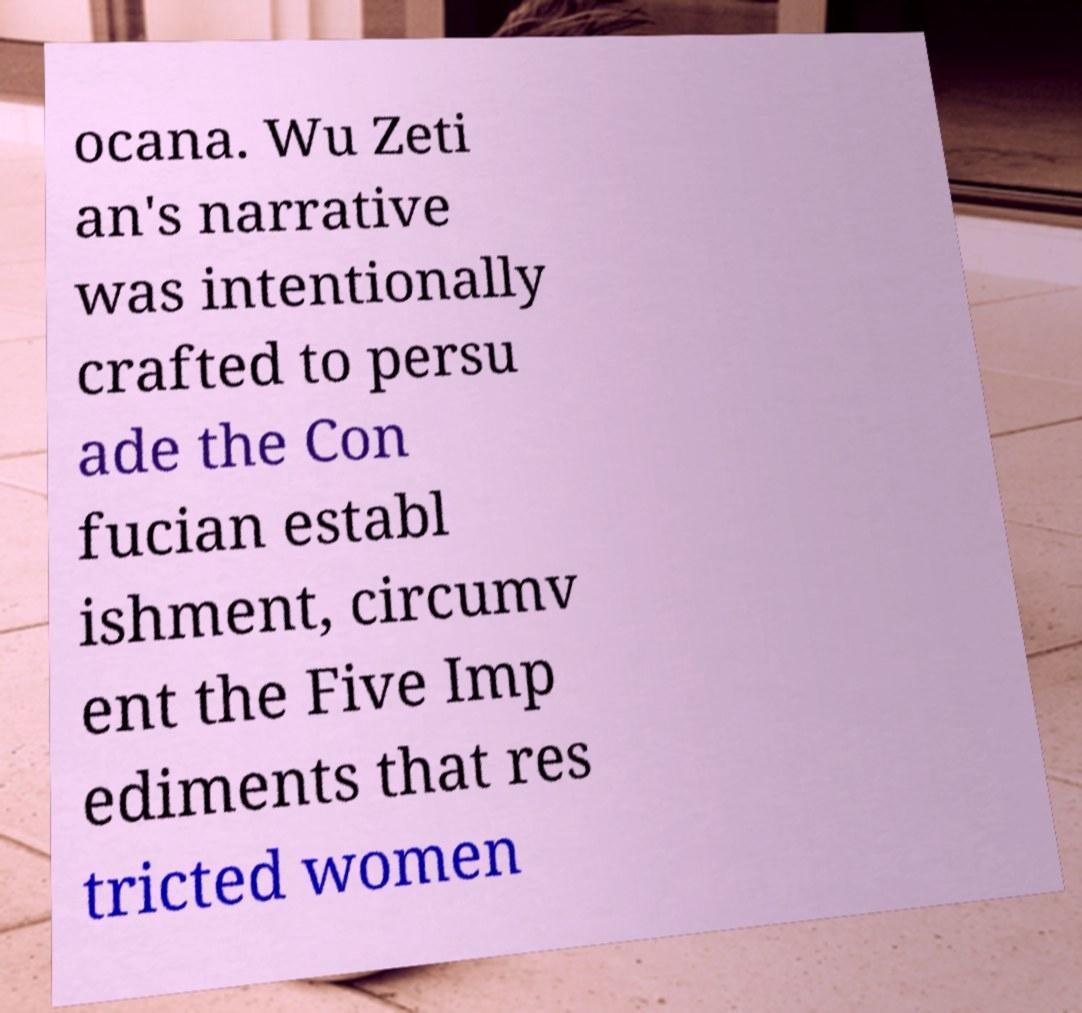Could you assist in decoding the text presented in this image and type it out clearly? ocana. Wu Zeti an's narrative was intentionally crafted to persu ade the Con fucian establ ishment, circumv ent the Five Imp ediments that res tricted women 